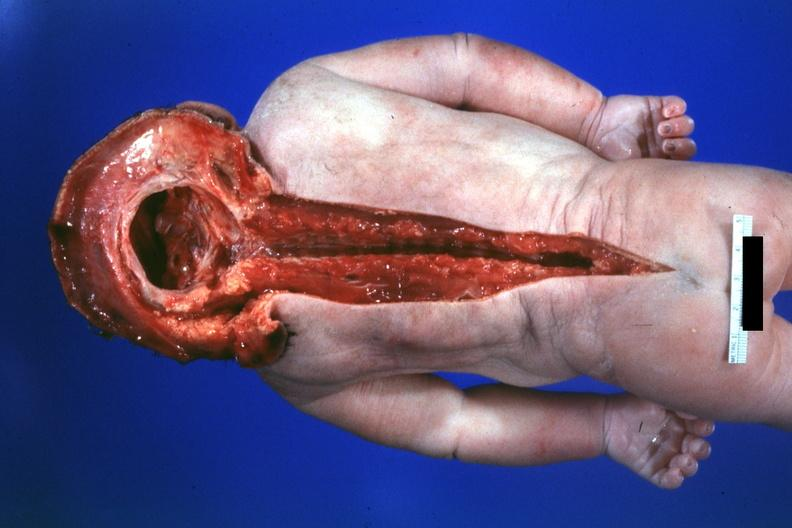does this image show dysraphism encephalocele occipital premature female no chromosomal defects lived one day?
Answer the question using a single word or phrase. Yes 